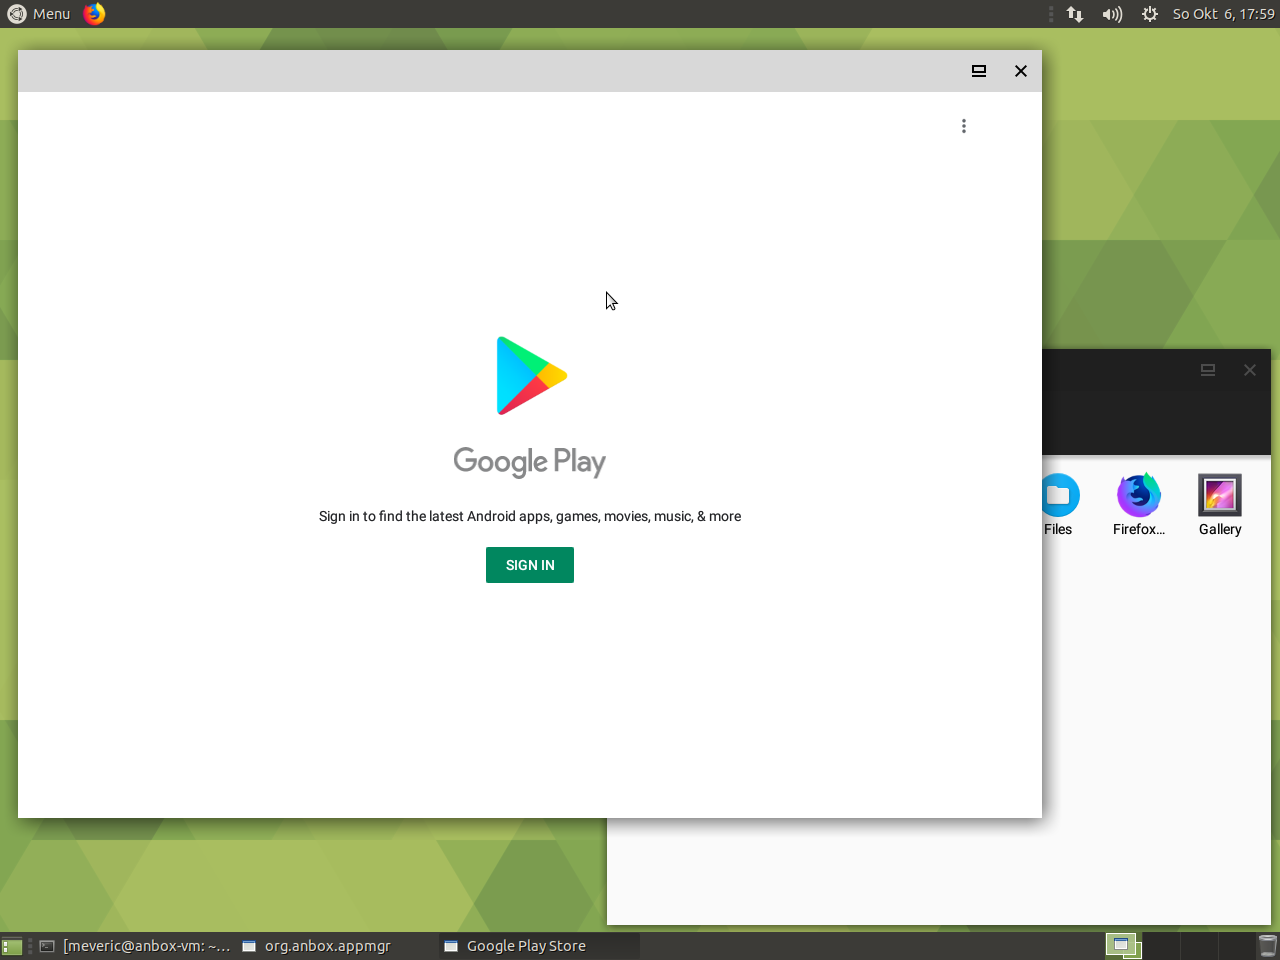Can you identify any specific software or features from the icons visible in the taskbar? In the taskbar of the image, there are few icons that can be identified. There's the 'Files' icon, which likely opens a file explorer to manage documents and media within the system. Next, we see a 'Firefox' icon, denoting the presence of the Firefox web browser, a popular open-source browser. Lastly, there's a 'Gallery' icon, which implies the existence of a photo viewer or image managing application. These icons provide useful insights into the types of software and features the user has quick access to for productivity and web-related tasks. 